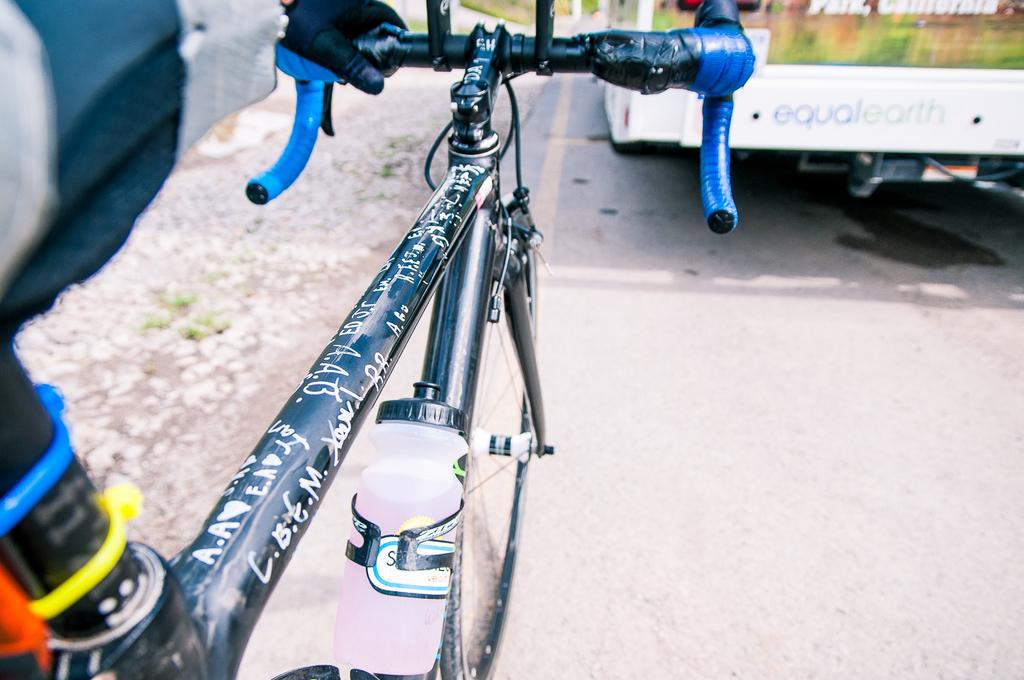What is the main mode of transportation in the image? There is a cycle in the image. Is there anything attached to the cycle? Yes, the cycle has a water bottle attached to it. Where is the cycle located in the image? The cycle is on the side of the road. What is in front of the cycle in the image? There is a bus in front of the cycle. What type of riddle can be solved using the bed in the image? There is no bed present in the image, so it cannot be used to solve any riddles. 